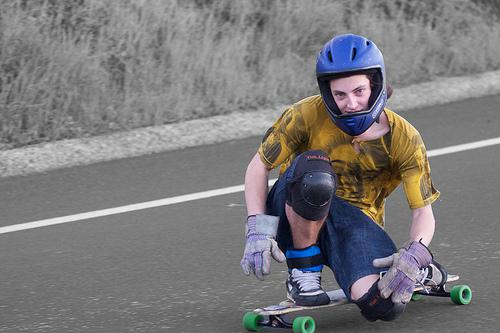Question: where was this photo taken?
Choices:
A. Inside a home.
B. On the street.
C. From a moving car.
D. China.
Answer with the letter. Answer: B Question: who is the focus of this photo?
Choices:
A. The man.
B. The woman.
C. The girl.
D. The baby.
Answer with the letter. Answer: A Question: why was this photo illuminated?
Choices:
A. Photo flash.
B. Additional strobe lights.
C. Sunlight.
D. Large lightening bolts.
Answer with the letter. Answer: C Question: what color is the man's shirt?
Choices:
A. Black.
B. Blue.
C. Yellow.
D. Red.
Answer with the letter. Answer: C 